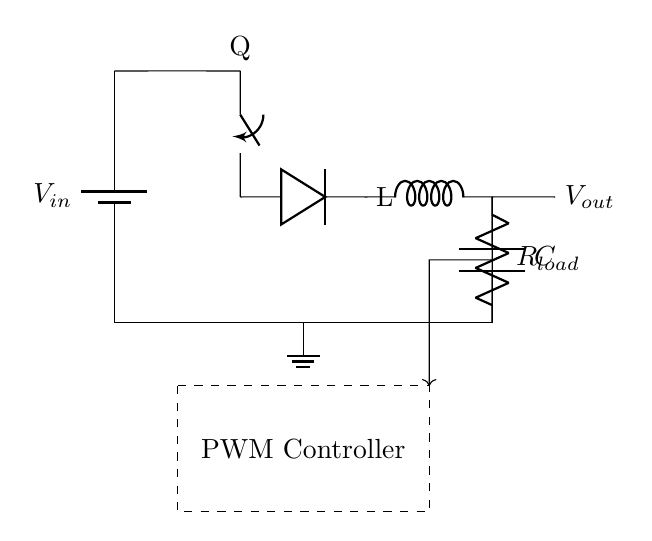What type of regulator is this circuit? This circuit is a switching regulator, which is indicated by the presence of a switch, inductor, and PWM controller. These components work together to efficiently convert a higher DC voltage to a lower DC voltage.
Answer: Switching regulator What are the main components in this circuit? The main components include a switch (Q), a diode (D), an inductor (L), a capacitor (C), a load resistor (R load), and a PWM controller. Each serves a specific role in the regulation process.
Answer: Switch, diode, inductor, capacitor, load resistor, PWM controller What is the purpose of the inductor? The inductor stores energy when current flows through it and releases energy to maintain a steady output voltage, helping to smooth out fluctuations in current.
Answer: Energy storage What is the role of the PWM controller? The PWM controller regulates the duty cycle of the switching signal to control the output voltage by adjusting the time the switch is on versus off, effectively managing power delivery.
Answer: Regulation of duty cycle What happens to the output voltage if the load resistance increases? If the load resistance increases, the output voltage typically rises because less current is drawn from the circuit, leading to a higher voltage across the load, assuming the regulator maintains regulation.
Answer: Output voltage rises How does the diode operate in this circuit? The diode conducts current when the switch is off, allowing the inductor to transfer energy to the output and prevent backflow of current when the switch is on, ensuring proper functioning of the regulator.
Answer: Conducts current 